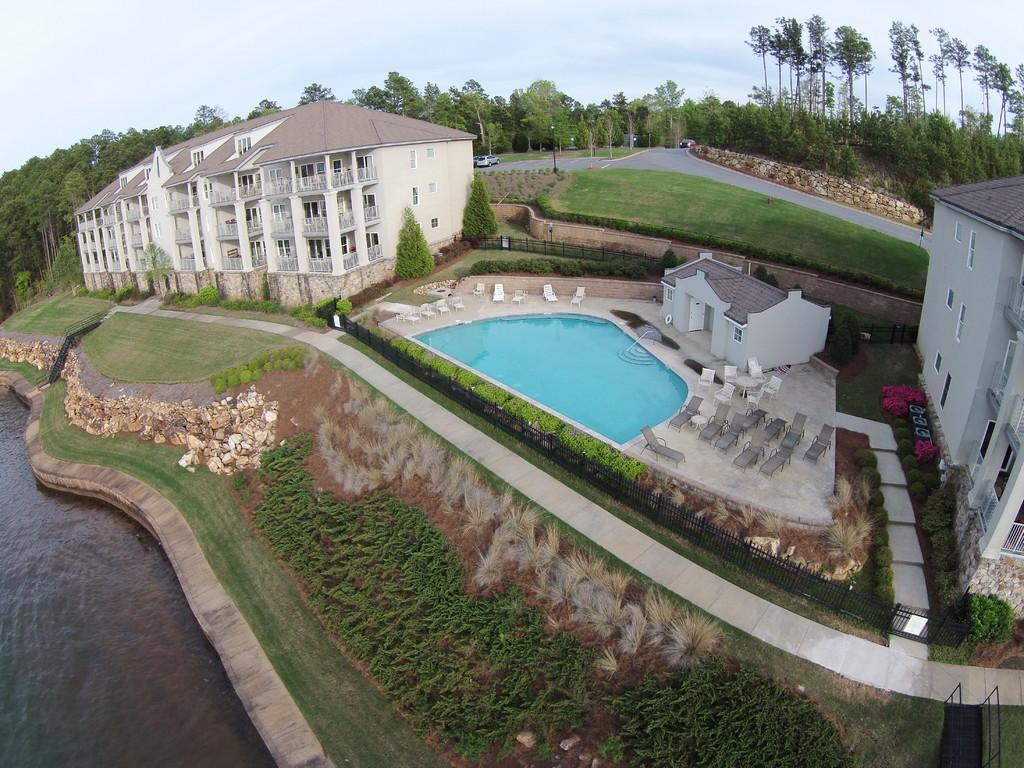What type of structures can be seen in the image? There are buildings in the image. What recreational feature is present in the image? There is a swimming pool in the image. What type of vegetation is visible in the image? There is grass in the image. What natural element is visible in the image? There is water visible in the image. What can be seen in the background of the image? There are trees and a vehicle on the road in the background of the image. What is visible in the sky in the image? The sky is visible in the background of the image. How many beans are present in the image? There are no beans visible in the image. What type of field is shown in the image? There is no field present in the image. 